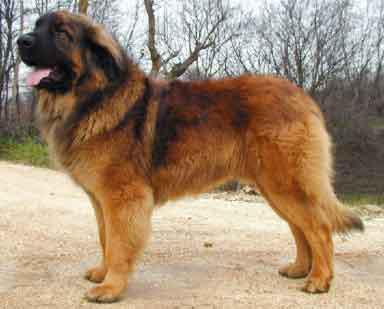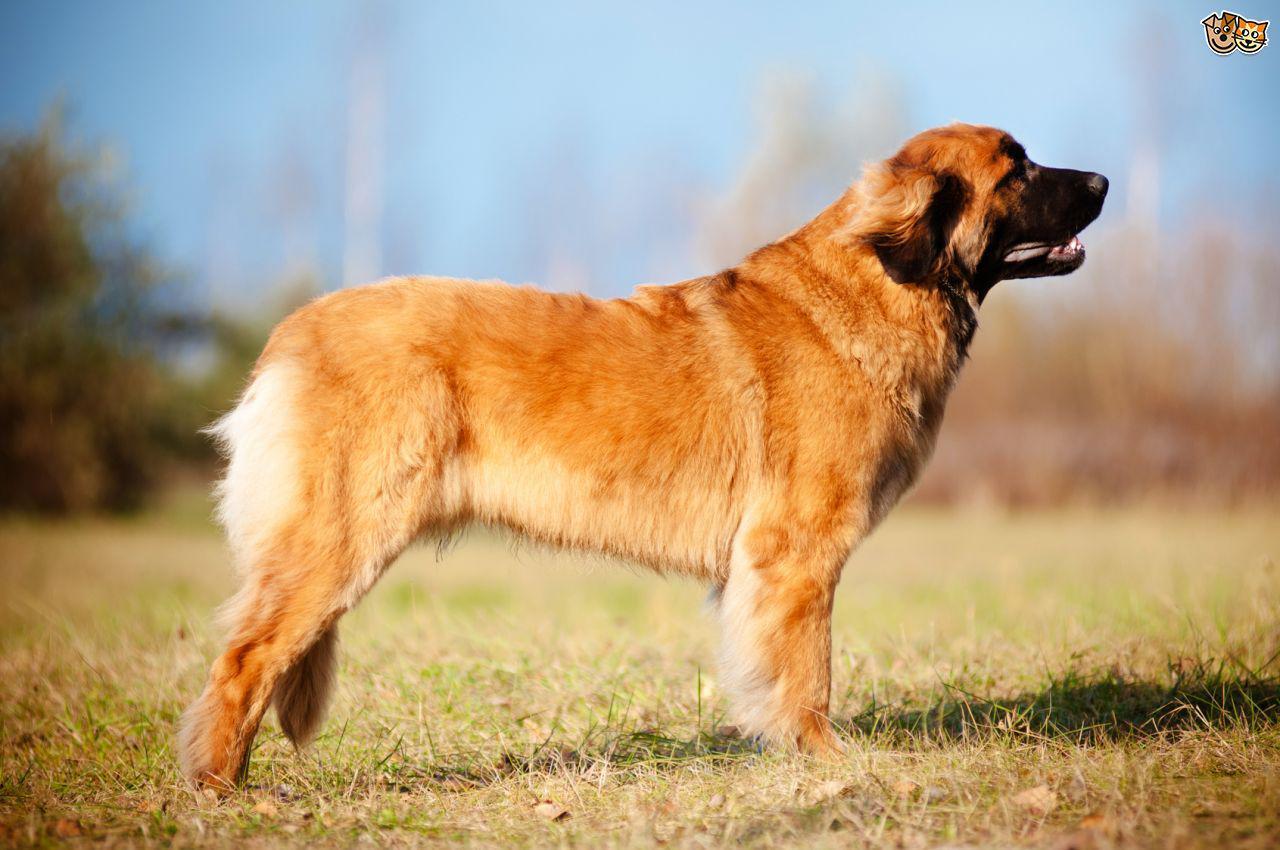The first image is the image on the left, the second image is the image on the right. Given the left and right images, does the statement "The dog in the image on the right is standing in full profile facing the right." hold true? Answer yes or no. Yes. 